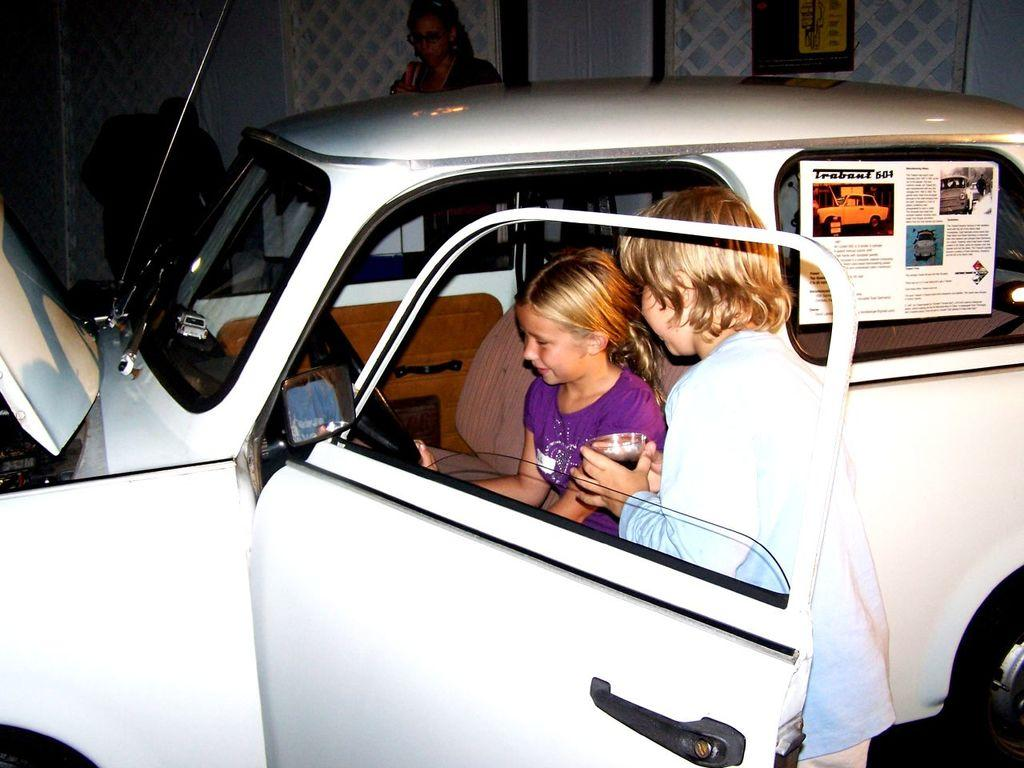Who is present in the image? There are children in the image. What are the children doing in the image? The children are trying to sit in a car. Where is the car located in relation to the children? The car is present in front of the children. Are there any other individuals present in the image? Yes, there are other people present in the image. What type of bird can be seen flying in the image? There is no bird visible in the image; it features children trying to sit in a car. How does the rain affect the children's ability to sit in the car? There is no rain present in the image, so its effect on the children's actions cannot be determined. 